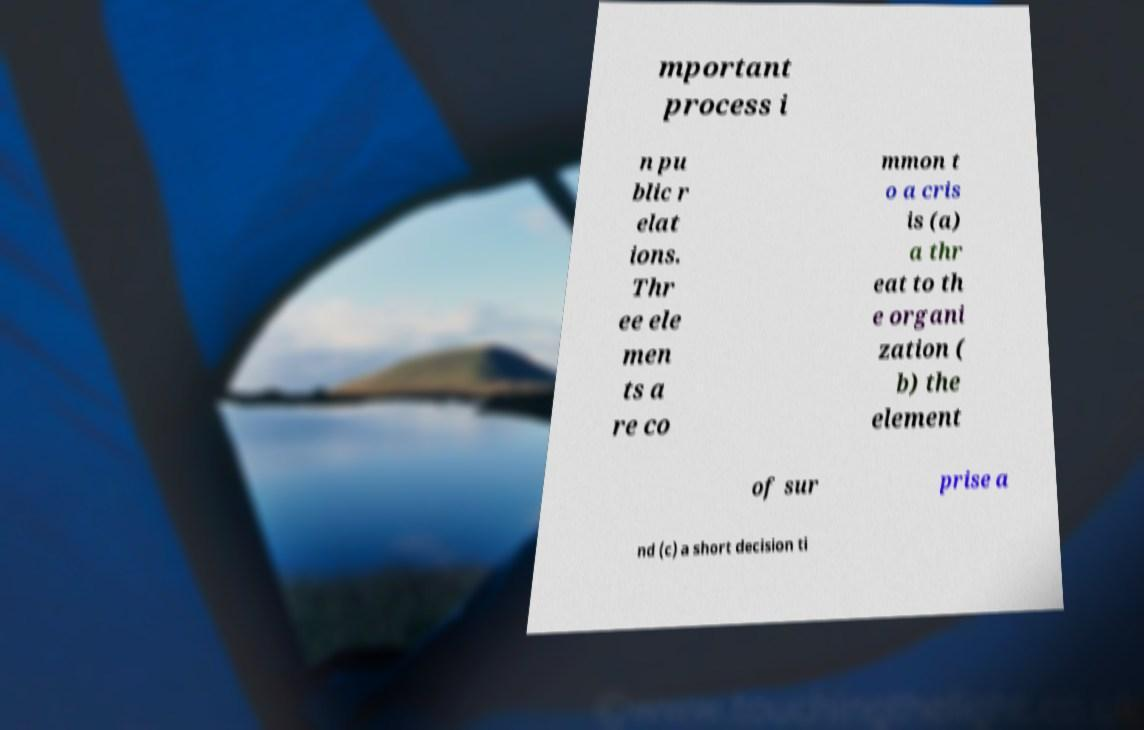Could you assist in decoding the text presented in this image and type it out clearly? mportant process i n pu blic r elat ions. Thr ee ele men ts a re co mmon t o a cris is (a) a thr eat to th e organi zation ( b) the element of sur prise a nd (c) a short decision ti 